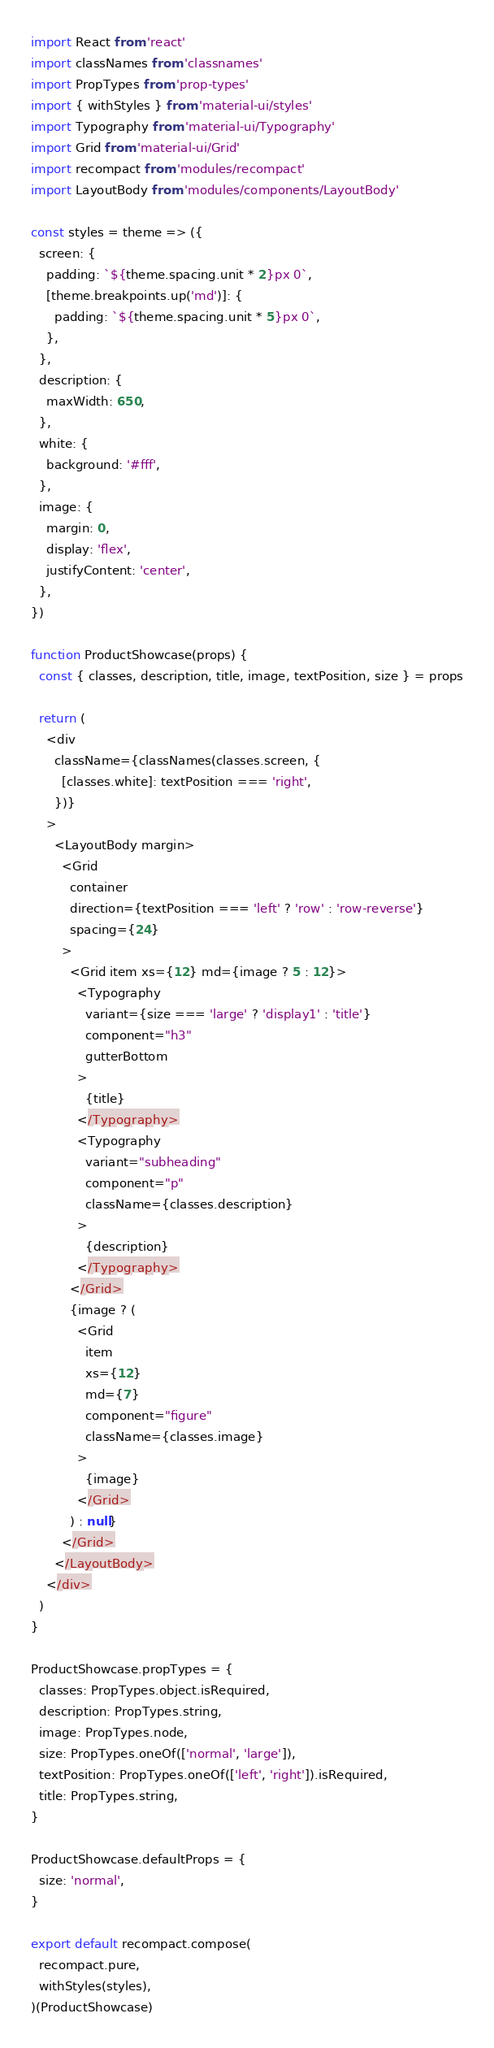<code> <loc_0><loc_0><loc_500><loc_500><_JavaScript_>import React from 'react'
import classNames from 'classnames'
import PropTypes from 'prop-types'
import { withStyles } from 'material-ui/styles'
import Typography from 'material-ui/Typography'
import Grid from 'material-ui/Grid'
import recompact from 'modules/recompact'
import LayoutBody from 'modules/components/LayoutBody'

const styles = theme => ({
  screen: {
    padding: `${theme.spacing.unit * 2}px 0`,
    [theme.breakpoints.up('md')]: {
      padding: `${theme.spacing.unit * 5}px 0`,
    },
  },
  description: {
    maxWidth: 650,
  },
  white: {
    background: '#fff',
  },
  image: {
    margin: 0,
    display: 'flex',
    justifyContent: 'center',
  },
})

function ProductShowcase(props) {
  const { classes, description, title, image, textPosition, size } = props

  return (
    <div
      className={classNames(classes.screen, {
        [classes.white]: textPosition === 'right',
      })}
    >
      <LayoutBody margin>
        <Grid
          container
          direction={textPosition === 'left' ? 'row' : 'row-reverse'}
          spacing={24}
        >
          <Grid item xs={12} md={image ? 5 : 12}>
            <Typography
              variant={size === 'large' ? 'display1' : 'title'}
              component="h3"
              gutterBottom
            >
              {title}
            </Typography>
            <Typography
              variant="subheading"
              component="p"
              className={classes.description}
            >
              {description}
            </Typography>
          </Grid>
          {image ? (
            <Grid
              item
              xs={12}
              md={7}
              component="figure"
              className={classes.image}
            >
              {image}
            </Grid>
          ) : null}
        </Grid>
      </LayoutBody>
    </div>
  )
}

ProductShowcase.propTypes = {
  classes: PropTypes.object.isRequired,
  description: PropTypes.string,
  image: PropTypes.node,
  size: PropTypes.oneOf(['normal', 'large']),
  textPosition: PropTypes.oneOf(['left', 'right']).isRequired,
  title: PropTypes.string,
}

ProductShowcase.defaultProps = {
  size: 'normal',
}

export default recompact.compose(
  recompact.pure,
  withStyles(styles),
)(ProductShowcase)
</code> 